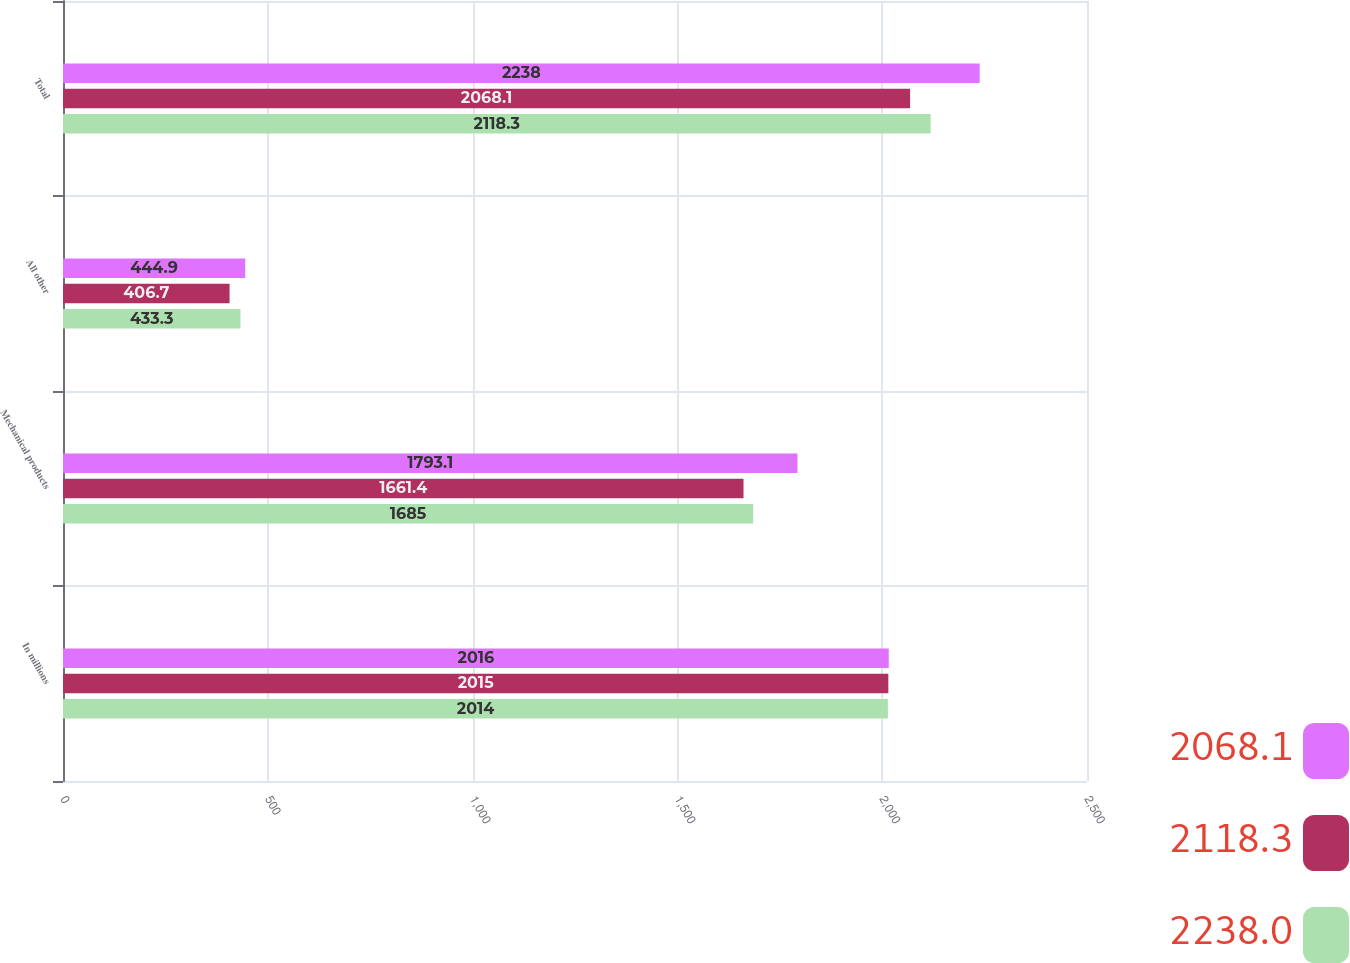Convert chart to OTSL. <chart><loc_0><loc_0><loc_500><loc_500><stacked_bar_chart><ecel><fcel>In millions<fcel>Mechanical products<fcel>All other<fcel>Total<nl><fcel>2068.1<fcel>2016<fcel>1793.1<fcel>444.9<fcel>2238<nl><fcel>2118.3<fcel>2015<fcel>1661.4<fcel>406.7<fcel>2068.1<nl><fcel>2238<fcel>2014<fcel>1685<fcel>433.3<fcel>2118.3<nl></chart> 